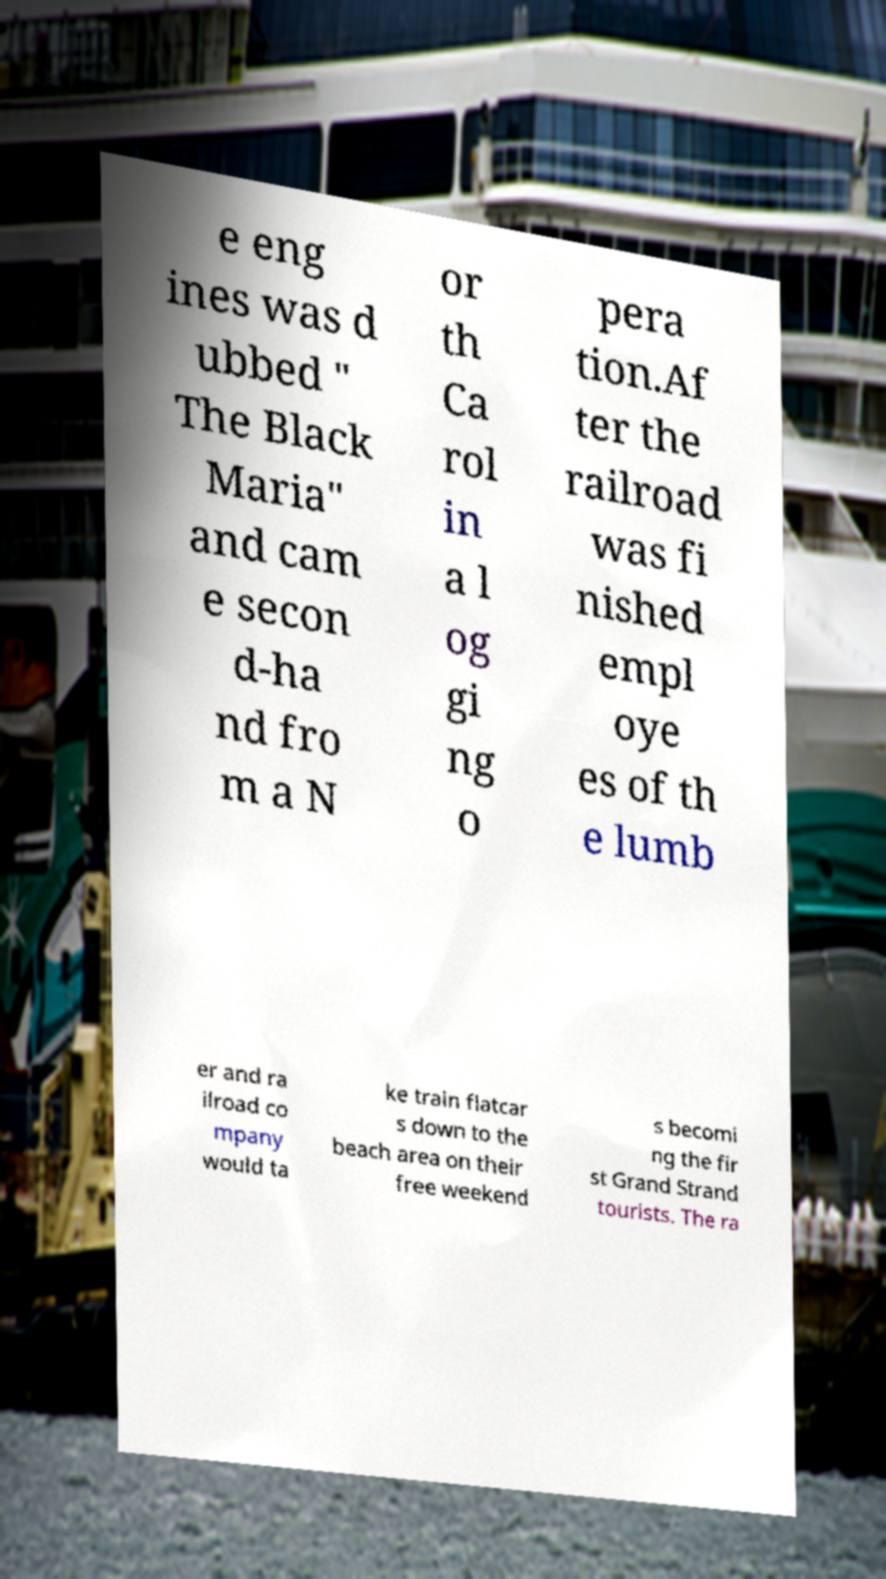There's text embedded in this image that I need extracted. Can you transcribe it verbatim? e eng ines was d ubbed " The Black Maria" and cam e secon d-ha nd fro m a N or th Ca rol in a l og gi ng o pera tion.Af ter the railroad was fi nished empl oye es of th e lumb er and ra ilroad co mpany would ta ke train flatcar s down to the beach area on their free weekend s becomi ng the fir st Grand Strand tourists. The ra 